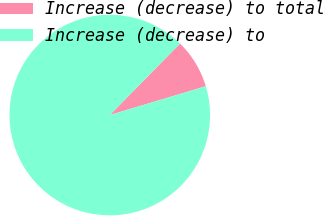<chart> <loc_0><loc_0><loc_500><loc_500><pie_chart><fcel>Increase (decrease) to total<fcel>Increase (decrease) to<nl><fcel>8.0%<fcel>92.0%<nl></chart> 